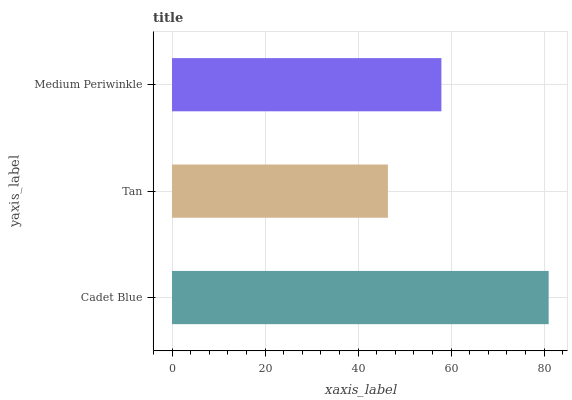Is Tan the minimum?
Answer yes or no. Yes. Is Cadet Blue the maximum?
Answer yes or no. Yes. Is Medium Periwinkle the minimum?
Answer yes or no. No. Is Medium Periwinkle the maximum?
Answer yes or no. No. Is Medium Periwinkle greater than Tan?
Answer yes or no. Yes. Is Tan less than Medium Periwinkle?
Answer yes or no. Yes. Is Tan greater than Medium Periwinkle?
Answer yes or no. No. Is Medium Periwinkle less than Tan?
Answer yes or no. No. Is Medium Periwinkle the high median?
Answer yes or no. Yes. Is Medium Periwinkle the low median?
Answer yes or no. Yes. Is Tan the high median?
Answer yes or no. No. Is Cadet Blue the low median?
Answer yes or no. No. 